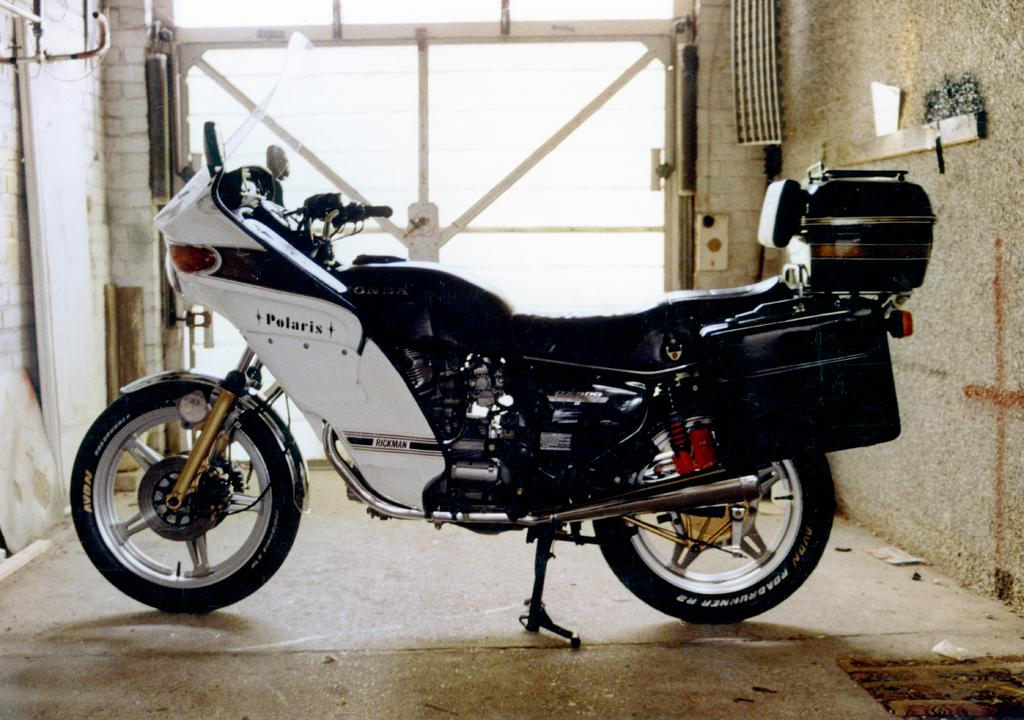What is the main subject of the image? The main subject of the image is a motorbike. What colors are used for the motorbike? The motorbike is in white and black color. Are there any additional items attached to the motorbike? Yes, there are two boxes attached to the motorbike. What can be seen in the background of the image? There is a wall visible in the image. How many cups are placed on the motorbike in the image? There are no cups present on the motorbike in the image. What type of machine is attached to the motorbike in the image? There is no machine attached to the motorbike in the image; only two boxes are present. 